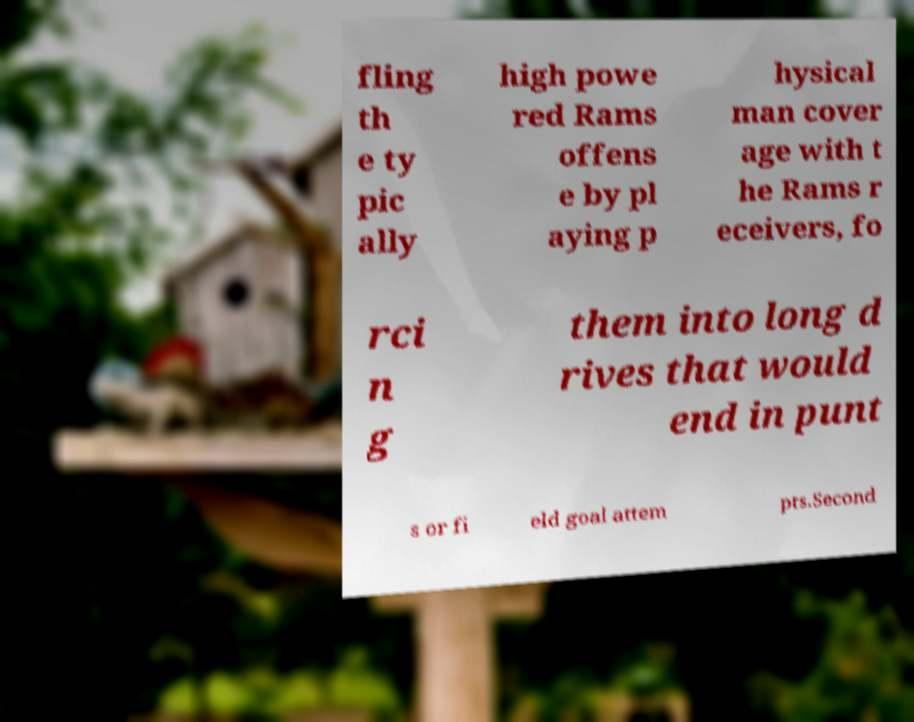Please identify and transcribe the text found in this image. fling th e ty pic ally high powe red Rams offens e by pl aying p hysical man cover age with t he Rams r eceivers, fo rci n g them into long d rives that would end in punt s or fi eld goal attem pts.Second 